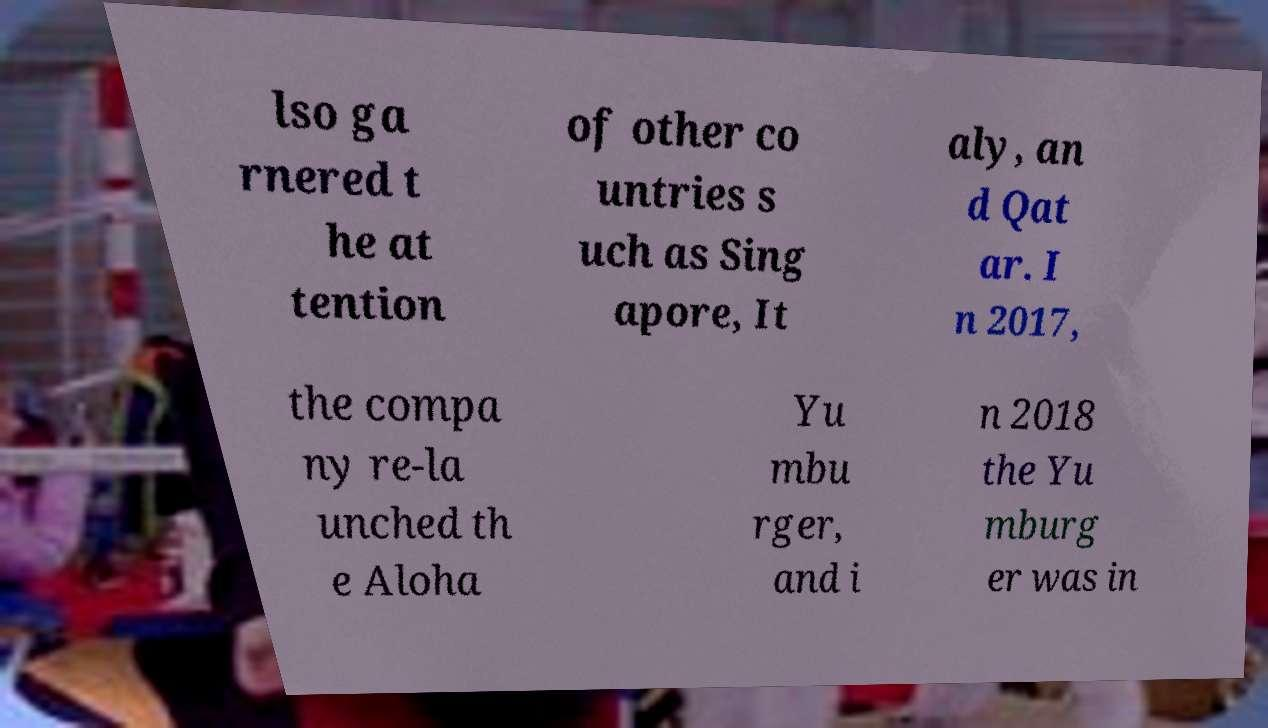Please identify and transcribe the text found in this image. lso ga rnered t he at tention of other co untries s uch as Sing apore, It aly, an d Qat ar. I n 2017, the compa ny re-la unched th e Aloha Yu mbu rger, and i n 2018 the Yu mburg er was in 